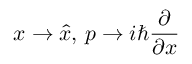<formula> <loc_0><loc_0><loc_500><loc_500>x \to { \hat { x } } , \, p \to i \hbar { \frac { \partial } { \partial x } }</formula> 